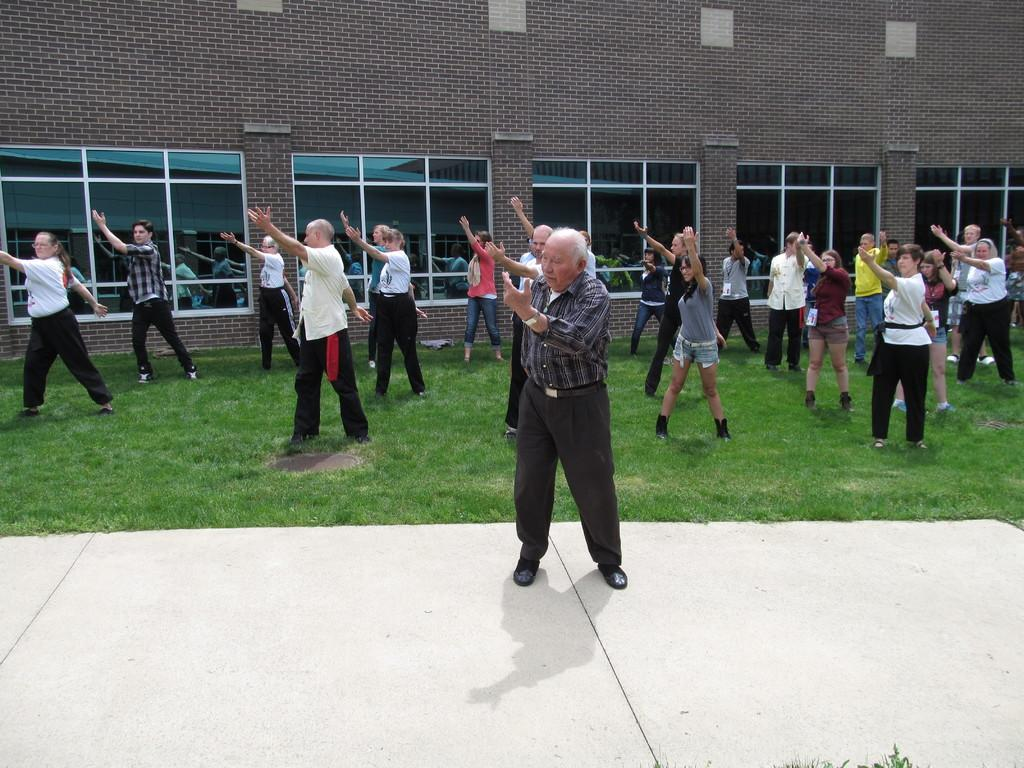What are the people in the image doing? The people in the image are exercising. What can be seen in the background of the image? There is a building in the background of some sort in the background of the image. What type of surface is visible at the bottom of the image? There is grass visible at the bottom of the image. How many feet are there in the image? There is no specific mention of feet in the image, so it is impossible to determine the number of feet present. 